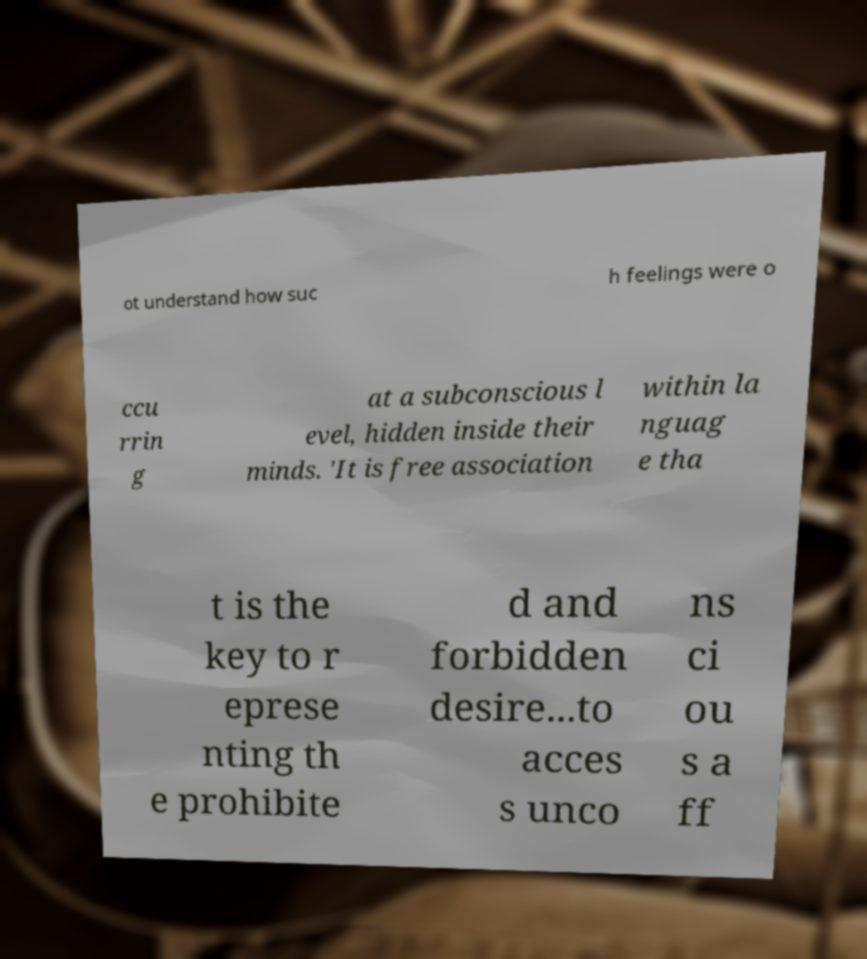For documentation purposes, I need the text within this image transcribed. Could you provide that? ot understand how suc h feelings were o ccu rrin g at a subconscious l evel, hidden inside their minds. 'It is free association within la nguag e tha t is the key to r eprese nting th e prohibite d and forbidden desire...to acces s unco ns ci ou s a ff 